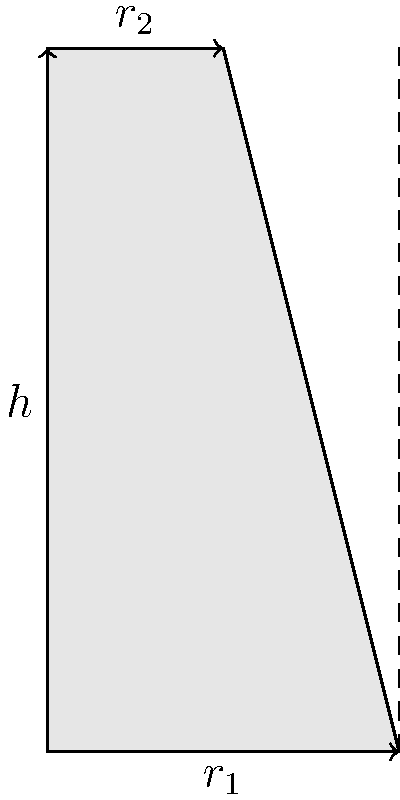As a science expert assisting authors with accurate scientific concepts, you encounter a problem involving a truncated cone. The cone has a height of 6 units, a lower radius ($r_1$) of 3 units, and an upper radius ($r_2$) of 1.5 units. Calculate the volume of this truncated cone to ensure the author's description is mathematically correct. To calculate the volume of a truncated cone, we'll follow these steps:

1) The formula for the volume of a truncated cone is:

   $$V = \frac{1}{3}\pi h(R^2 + r^2 + Rr)$$

   where $h$ is the height, $R$ is the radius of the base, and $r$ is the radius of the top.

2) We have the following values:
   $h = 6$ units
   $R = r_1 = 3$ units
   $r = r_2 = 1.5$ units

3) Let's substitute these values into the formula:

   $$V = \frac{1}{3}\pi \cdot 6(3^2 + 1.5^2 + 3 \cdot 1.5)$$

4) Simplify the expressions inside the parentheses:
   $$V = 2\pi(9 + 2.25 + 4.5)$$

5) Add the terms inside the parentheses:
   $$V = 2\pi(15.75)$$

6) Multiply:
   $$V = 31.5\pi$$

7) If we need a decimal approximation, we can calculate:
   $$V \approx 98.96 \text{ cubic units}$$

Thus, the volume of the truncated cone is $31.5\pi$ or approximately 98.96 cubic units.
Answer: $31.5\pi$ cubic units 